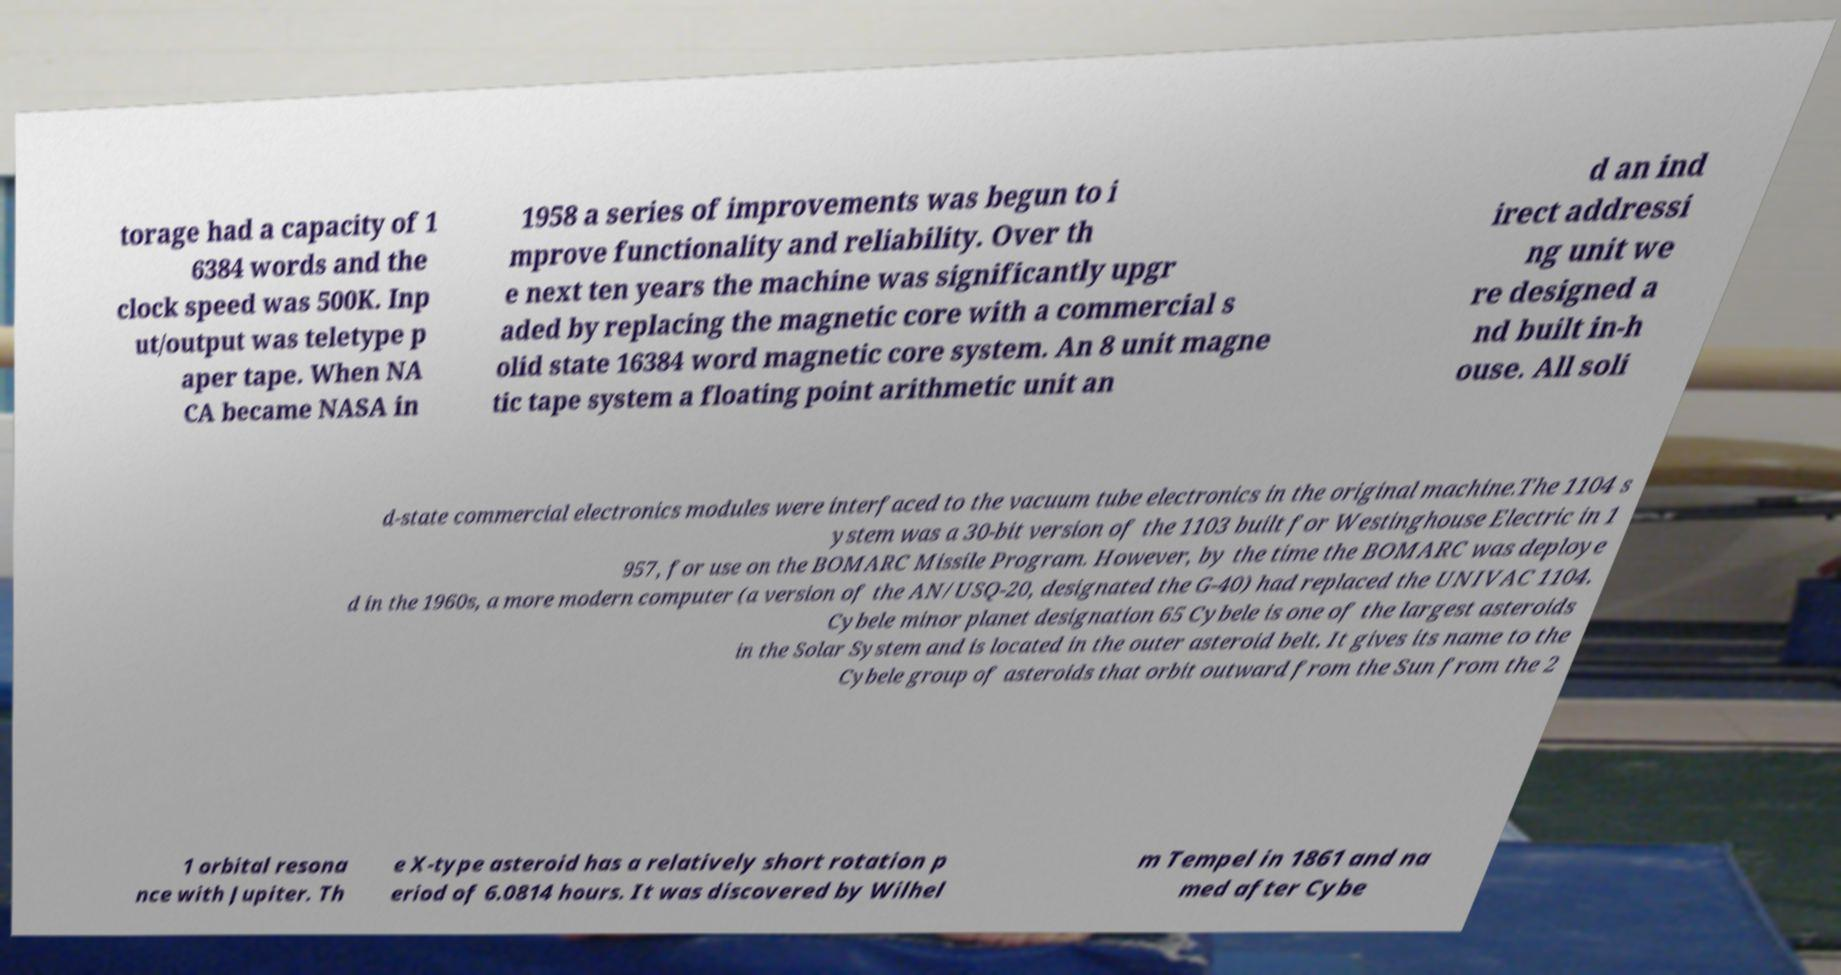Please identify and transcribe the text found in this image. torage had a capacity of 1 6384 words and the clock speed was 500K. Inp ut/output was teletype p aper tape. When NA CA became NASA in 1958 a series of improvements was begun to i mprove functionality and reliability. Over th e next ten years the machine was significantly upgr aded by replacing the magnetic core with a commercial s olid state 16384 word magnetic core system. An 8 unit magne tic tape system a floating point arithmetic unit an d an ind irect addressi ng unit we re designed a nd built in-h ouse. All soli d-state commercial electronics modules were interfaced to the vacuum tube electronics in the original machine.The 1104 s ystem was a 30-bit version of the 1103 built for Westinghouse Electric in 1 957, for use on the BOMARC Missile Program. However, by the time the BOMARC was deploye d in the 1960s, a more modern computer (a version of the AN/USQ-20, designated the G-40) had replaced the UNIVAC 1104. Cybele minor planet designation 65 Cybele is one of the largest asteroids in the Solar System and is located in the outer asteroid belt. It gives its name to the Cybele group of asteroids that orbit outward from the Sun from the 2 1 orbital resona nce with Jupiter. Th e X-type asteroid has a relatively short rotation p eriod of 6.0814 hours. It was discovered by Wilhel m Tempel in 1861 and na med after Cybe 